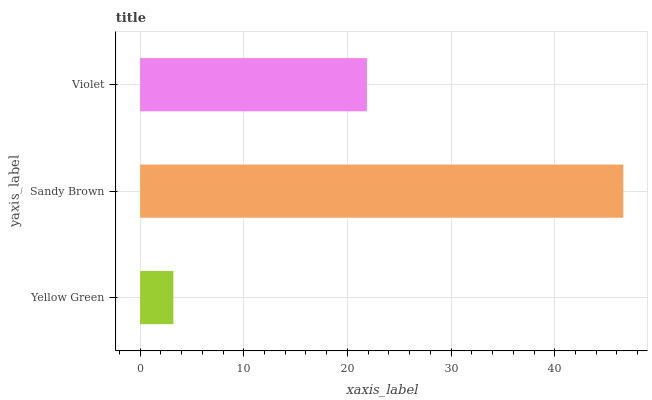Is Yellow Green the minimum?
Answer yes or no. Yes. Is Sandy Brown the maximum?
Answer yes or no. Yes. Is Violet the minimum?
Answer yes or no. No. Is Violet the maximum?
Answer yes or no. No. Is Sandy Brown greater than Violet?
Answer yes or no. Yes. Is Violet less than Sandy Brown?
Answer yes or no. Yes. Is Violet greater than Sandy Brown?
Answer yes or no. No. Is Sandy Brown less than Violet?
Answer yes or no. No. Is Violet the high median?
Answer yes or no. Yes. Is Violet the low median?
Answer yes or no. Yes. Is Sandy Brown the high median?
Answer yes or no. No. Is Sandy Brown the low median?
Answer yes or no. No. 